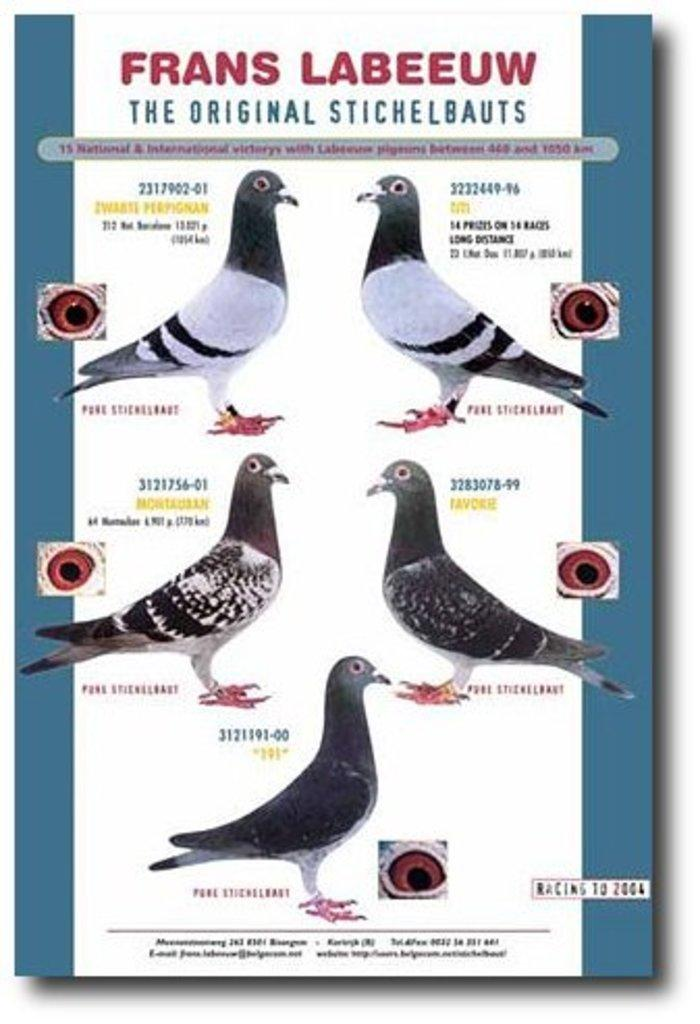What is featured on the poster in the image? The image contains a poster with birds depicted on it. What else can be seen on the poster besides the birds? There is text present on the poster. What type of stitch is used to create the birds on the poster? There is no indication in the image that the birds on the poster were created using any type of stitch, as the image is likely a printed poster. What type of silk is used to make the poster? There is no mention of silk being used to make the poster; it is simply a printed poster. 